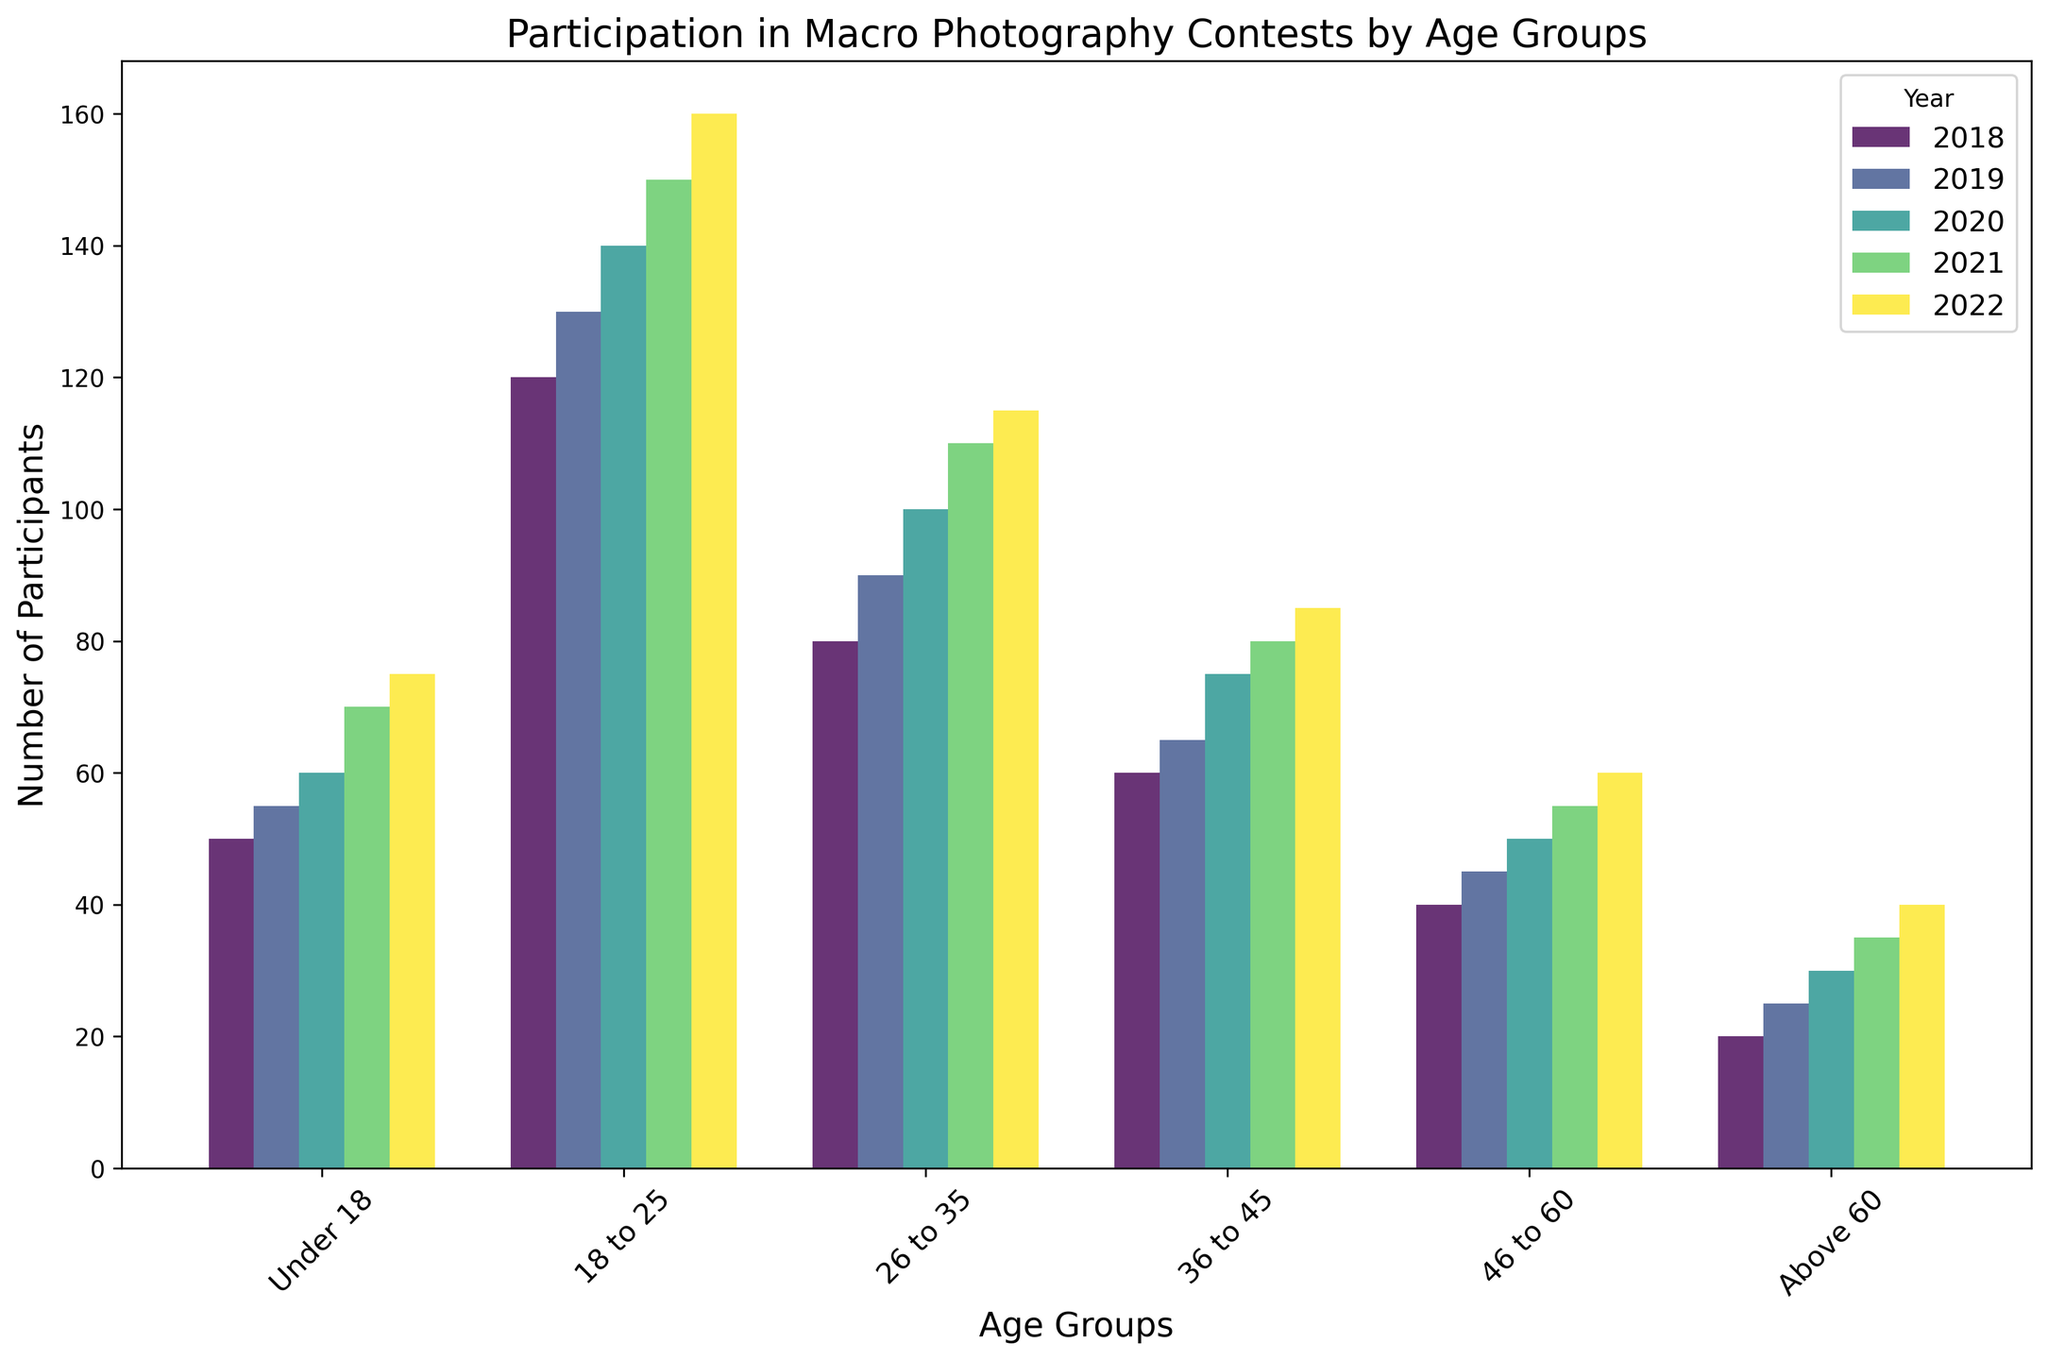What's the trend in participation for 18 to 25-year-olds from 2018 to 2022? By examining the heights of the bars for the 18 to 25 age group from 2018 to 2022, we can see that the number of participants increases each year. Starting from 120 in 2018, it rises to 130 in 2019, 140 in 2020, 150 in 2021, and then 160 in 2022.
Answer: Increasing Which age group had the highest participation in 2022? Observing the heights of the bars for the different age groups in 2022, the 18 to 25-year-olds have the tallest bar, indicating the highest number of participants at 160.
Answer: 18 to 25 In which year did the Under 18 group see the most significant increase in participation compared to the previous year? To find the year with the most significant increase for the Under 18 group, calculate the differences in participation between consecutive years: 2018-2019 (5), 2019-2020 (5), 2020-2021 (10), 2021-2022 (5). The year 2020 to 2021 shows the highest increase of 10 participants.
Answer: 2021 Comparing 2020, which age group saw the least number of participants? By comparing the bars for 2020, the Above 60 age group has the smallest bar, indicating the least number of participants, which is 30.
Answer: Above 60 What is the average number of participants for the 36 to 45 age group from 2018 to 2022? Add the number of participants for the 36 to 45 age group from 2018 to 2022 and divide by 5: (60 + 65 + 75 + 80 + 85) / 5 = 365 / 5 = 73.
Answer: 73 Which age group had the lowest total participation over the years 2018 to 2022? Sum the participation numbers for each age group across all years. The Under 18 group sums to 310, 18 to 25 sums to 700, 26 to 35 sums to 495, 36 to 45 sums to 365, 46 to 60 sums to 250, and Above 60 sums to 150. The Above 60 group has the lowest total of 150.
Answer: Above 60 How does the number of participants in 2018 for the 26 to 35 age group compare to the 46 to 60 age group? In 2018, the number of participants for the 26 to 35 age group is 80 and for the 46 to 60 age group is 40. The 26 to 35 age group has double the participants compared to the 46 to 60 age group.
Answer: Double Identify the year with the overall highest participation for all age groups combined. Sum the participation numbers for each year: 2018 (370), 2019 (410), 2020 (455), 2021 (500), and 2022 (535). The year 2022 has the highest total participation of 535.
Answer: 2022 